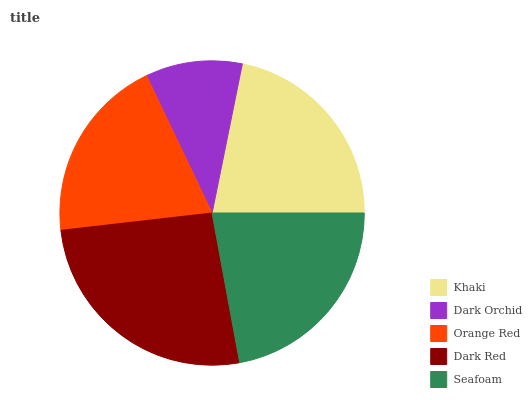Is Dark Orchid the minimum?
Answer yes or no. Yes. Is Dark Red the maximum?
Answer yes or no. Yes. Is Orange Red the minimum?
Answer yes or no. No. Is Orange Red the maximum?
Answer yes or no. No. Is Orange Red greater than Dark Orchid?
Answer yes or no. Yes. Is Dark Orchid less than Orange Red?
Answer yes or no. Yes. Is Dark Orchid greater than Orange Red?
Answer yes or no. No. Is Orange Red less than Dark Orchid?
Answer yes or no. No. Is Khaki the high median?
Answer yes or no. Yes. Is Khaki the low median?
Answer yes or no. Yes. Is Dark Red the high median?
Answer yes or no. No. Is Dark Red the low median?
Answer yes or no. No. 